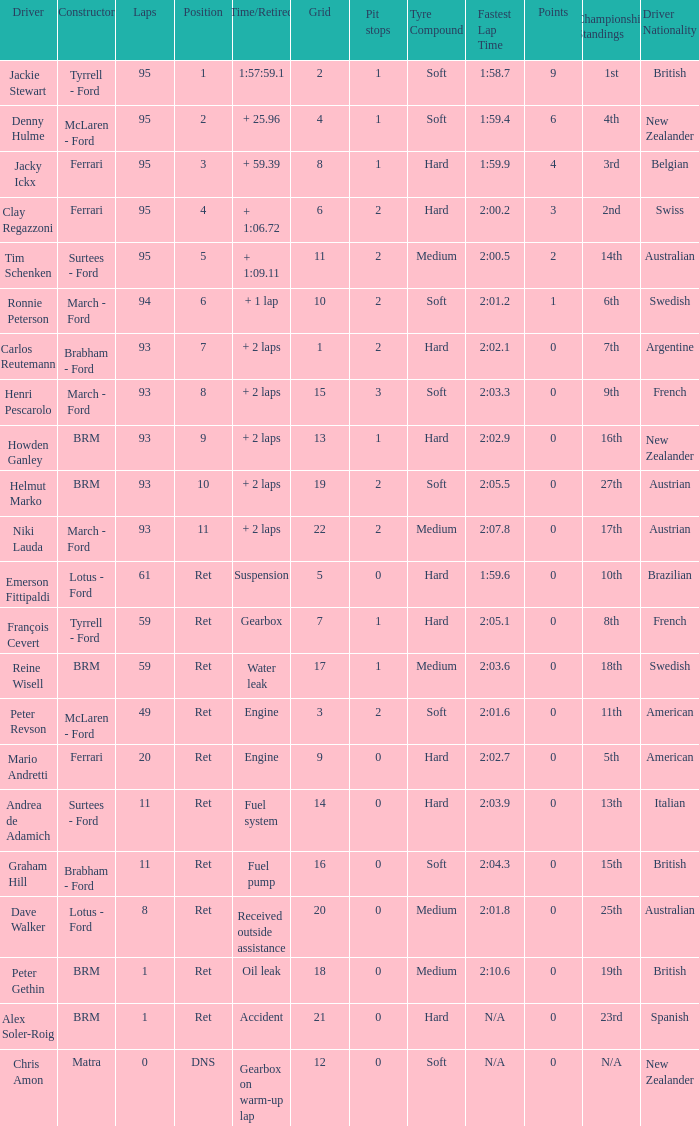How many grids are there in total for peter gethin? 18.0. Could you parse the entire table as a dict? {'header': ['Driver', 'Constructor', 'Laps', 'Position', 'Time/Retired', 'Grid', 'Pit stops', 'Tyre Compound', 'Fastest Lap Time', 'Points', 'Championship Standings', 'Driver Nationality'], 'rows': [['Jackie Stewart', 'Tyrrell - Ford', '95', '1', '1:57:59.1', '2', '1', 'Soft', '1:58.7', '9', '1st', 'British'], ['Denny Hulme', 'McLaren - Ford', '95', '2', '+ 25.96', '4', '1', 'Soft', '1:59.4', '6', '4th', 'New Zealander'], ['Jacky Ickx', 'Ferrari', '95', '3', '+ 59.39', '8', '1', 'Hard', '1:59.9', '4', '3rd', 'Belgian'], ['Clay Regazzoni', 'Ferrari', '95', '4', '+ 1:06.72', '6', '2', 'Hard', '2:00.2', '3', '2nd', 'Swiss'], ['Tim Schenken', 'Surtees - Ford', '95', '5', '+ 1:09.11', '11', '2', 'Medium', '2:00.5', '2', '14th', 'Australian'], ['Ronnie Peterson', 'March - Ford', '94', '6', '+ 1 lap', '10', '2', 'Soft', '2:01.2', '1', '6th', 'Swedish'], ['Carlos Reutemann', 'Brabham - Ford', '93', '7', '+ 2 laps', '1', '2', 'Hard', '2:02.1', '0', '7th', 'Argentine'], ['Henri Pescarolo', 'March - Ford', '93', '8', '+ 2 laps', '15', '3', 'Soft', '2:03.3', '0', '9th', 'French'], ['Howden Ganley', 'BRM', '93', '9', '+ 2 laps', '13', '1', 'Hard', '2:02.9', '0', '16th', 'New Zealander'], ['Helmut Marko', 'BRM', '93', '10', '+ 2 laps', '19', '2', 'Soft', '2:05.5', '0', '27th', 'Austrian'], ['Niki Lauda', 'March - Ford', '93', '11', '+ 2 laps', '22', '2', 'Medium', '2:07.8', '0', '17th', 'Austrian'], ['Emerson Fittipaldi', 'Lotus - Ford', '61', 'Ret', 'Suspension', '5', '0', 'Hard', '1:59.6', '0', '10th', 'Brazilian'], ['François Cevert', 'Tyrrell - Ford', '59', 'Ret', 'Gearbox', '7', '1', 'Hard', '2:05.1', '0', '8th', 'French'], ['Reine Wisell', 'BRM', '59', 'Ret', 'Water leak', '17', '1', 'Medium', '2:03.6', '0', '18th', 'Swedish'], ['Peter Revson', 'McLaren - Ford', '49', 'Ret', 'Engine', '3', '2', 'Soft', '2:01.6', '0', '11th', 'American'], ['Mario Andretti', 'Ferrari', '20', 'Ret', 'Engine', '9', '0', 'Hard', '2:02.7', '0', '5th', 'American'], ['Andrea de Adamich', 'Surtees - Ford', '11', 'Ret', 'Fuel system', '14', '0', 'Hard', '2:03.9', '0', '13th', 'Italian'], ['Graham Hill', 'Brabham - Ford', '11', 'Ret', 'Fuel pump', '16', '0', 'Soft', '2:04.3', '0', '15th', 'British'], ['Dave Walker', 'Lotus - Ford', '8', 'Ret', 'Received outside assistance', '20', '0', 'Medium', '2:01.8', '0', '25th', 'Australian'], ['Peter Gethin', 'BRM', '1', 'Ret', 'Oil leak', '18', '0', 'Medium', '2:10.6', '0', '19th', 'British'], ['Alex Soler-Roig', 'BRM', '1', 'Ret', 'Accident', '21', '0', 'Hard', 'N/A', '0', '23rd', 'Spanish'], ['Chris Amon', 'Matra', '0', 'DNS', 'Gearbox on warm-up lap', '12', '0', 'Soft', 'N/A', '0', 'N/A', 'New Zealander']]} 